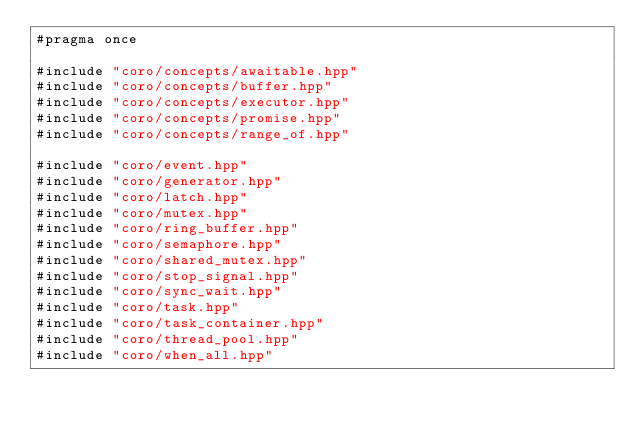Convert code to text. <code><loc_0><loc_0><loc_500><loc_500><_C++_>#pragma once

#include "coro/concepts/awaitable.hpp"
#include "coro/concepts/buffer.hpp"
#include "coro/concepts/executor.hpp"
#include "coro/concepts/promise.hpp"
#include "coro/concepts/range_of.hpp"

#include "coro/event.hpp"
#include "coro/generator.hpp"
#include "coro/latch.hpp"
#include "coro/mutex.hpp"
#include "coro/ring_buffer.hpp"
#include "coro/semaphore.hpp"
#include "coro/shared_mutex.hpp"
#include "coro/stop_signal.hpp"
#include "coro/sync_wait.hpp"
#include "coro/task.hpp"
#include "coro/task_container.hpp"
#include "coro/thread_pool.hpp"
#include "coro/when_all.hpp"
</code> 